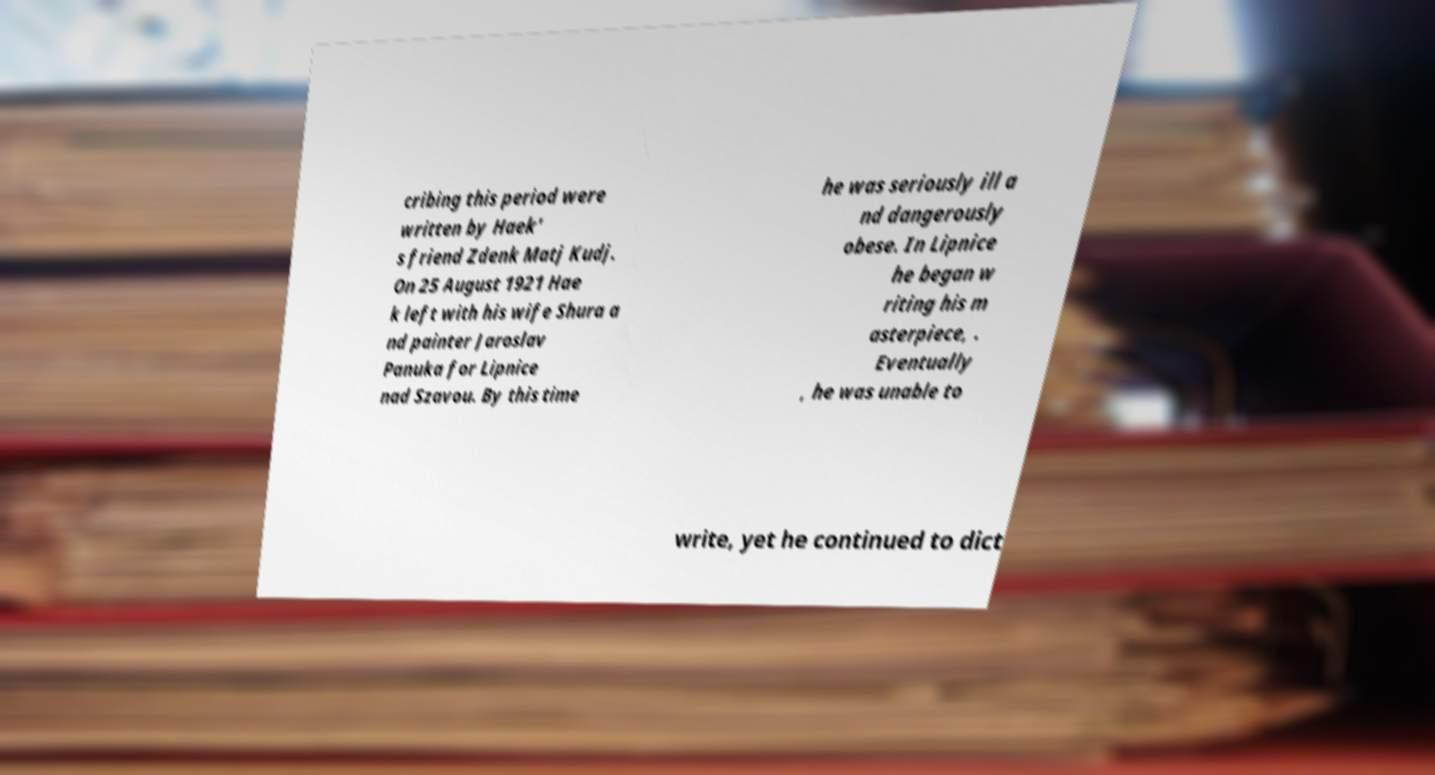For documentation purposes, I need the text within this image transcribed. Could you provide that? cribing this period were written by Haek' s friend Zdenk Matj Kudj. On 25 August 1921 Hae k left with his wife Shura a nd painter Jaroslav Panuka for Lipnice nad Szavou. By this time he was seriously ill a nd dangerously obese. In Lipnice he began w riting his m asterpiece, . Eventually , he was unable to write, yet he continued to dict 